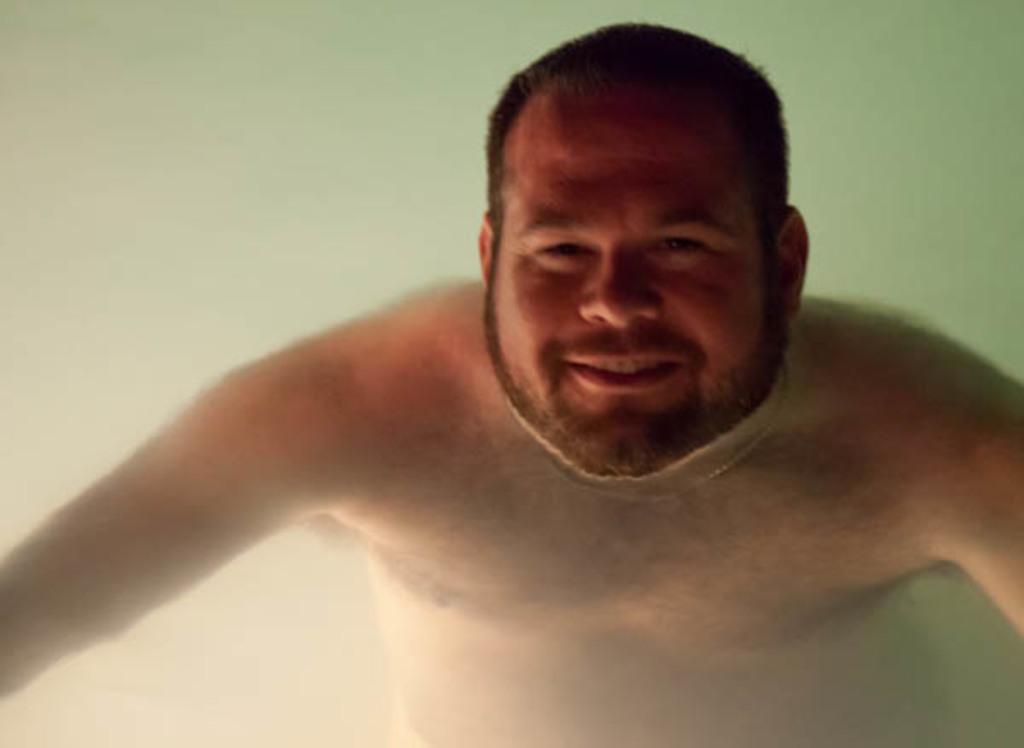Could you give a brief overview of what you see in this image? Here I can see a man is swimming in the water. He is smiling and giving pose for the picture. 